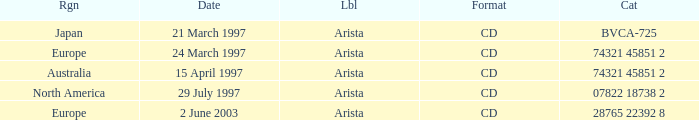What Format has the Region of Europe and a Catalog of 74321 45851 2? CD. 